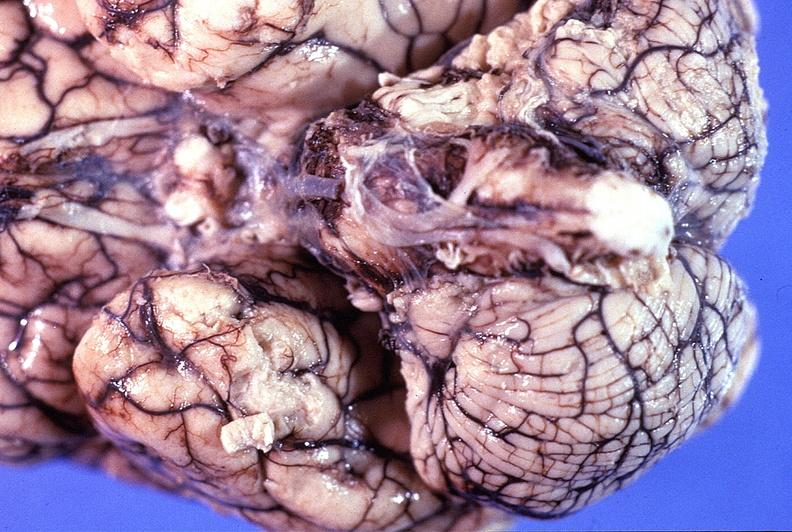s nervous present?
Answer the question using a single word or phrase. Yes 